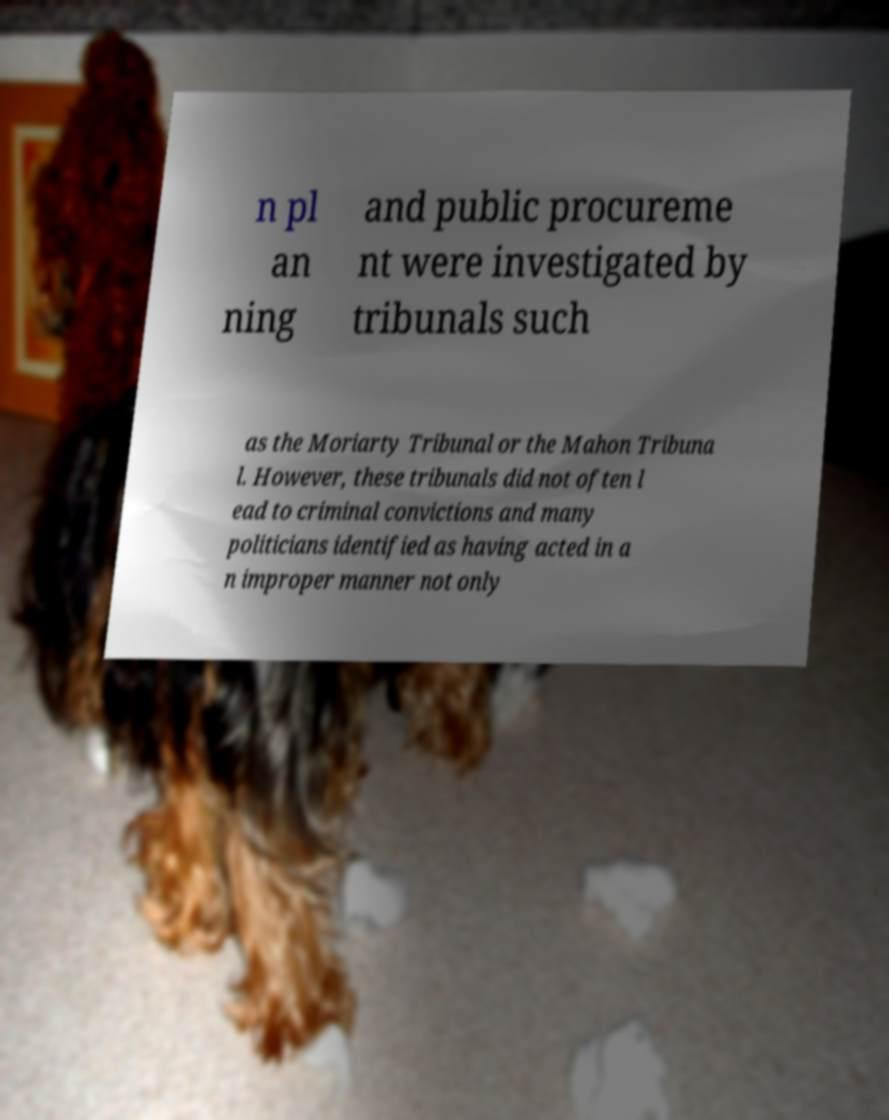Could you assist in decoding the text presented in this image and type it out clearly? n pl an ning and public procureme nt were investigated by tribunals such as the Moriarty Tribunal or the Mahon Tribuna l. However, these tribunals did not often l ead to criminal convictions and many politicians identified as having acted in a n improper manner not only 